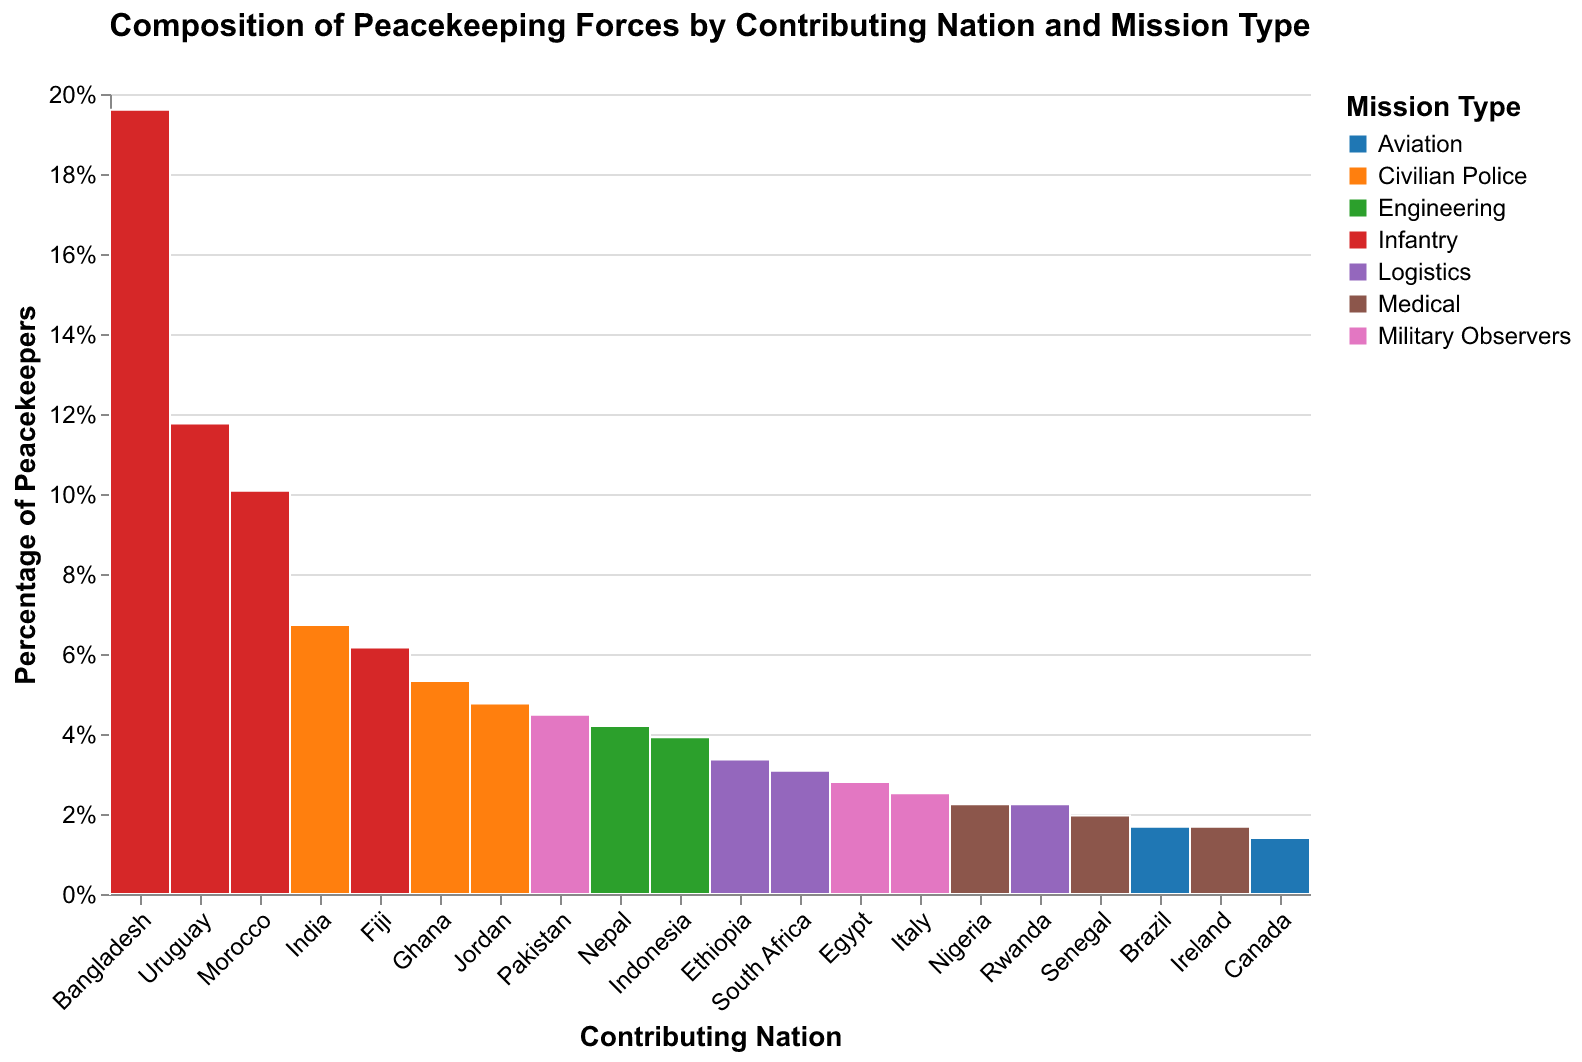What is the title of the mosaic plot? The title of the mosaic plot is located at the center top of the figure.
Answer: Composition of Peacekeeping Forces by Contributing Nation and Mission Type Which nation contributes the highest number of infantry peacekeepers? To identify the nation contributing the most infantry peacekeepers, look at the tallest segment in the 'Infantry' color across all nations.
Answer: Bangladesh How many peacekeepers does Fiji contribute to infantry missions? Find the segment corresponding to Fiji in the mosaic plot and identify the value for the infantry mission type.
Answer: 1100 Which mission type does Nigeria contribute to the most? Look at the different colored segments for Nigeria and find the one with the largest size.
Answer: Medical Compare the contributions of military observers from Pakistan and Italy. Which country contributes more? Examine the segments corresponding to 'Military Observers' for both Pakistan and Italy, and compare their sizes.
Answer: Pakistan Which nation contributes the largest number of civilian police peacekeepers, and what is this number? Find the largest segment in the 'Civilian Police' color and identify the corresponding nation and value.
Answer: India, 1200 What percentage of peacekeepers from Bangladesh are involved in infantry missions? Look at the segment for Bangladesh in the mosaic plot and check the corresponding percentage value for 'Infantry'.
Answer: Nearly 100% Which mission type has the smallest overall contribution from all nations combined? Aggregate the contributions across all nations for each mission type and identify the smallest sum.
Answer: Aviation Is there a significant difference in the number of engineering peacekeepers contributed by Nepal and Indonesia? Compare the sizes of the segments for 'Engineering' from Nepal and Indonesia. Identify if there is a notable size difference.
Answer: No, they're very similar (750 vs 700) What is the largest category in terms of peacekeepers for Italy, and how does it compare to Jordan's contribution in the same category? Look at the segments for Italy, identify the largest mission type, and compare it to the corresponding segment for Jordan.
Answer: Military Observers (450), less than Jordan's Civilian Police (850) 